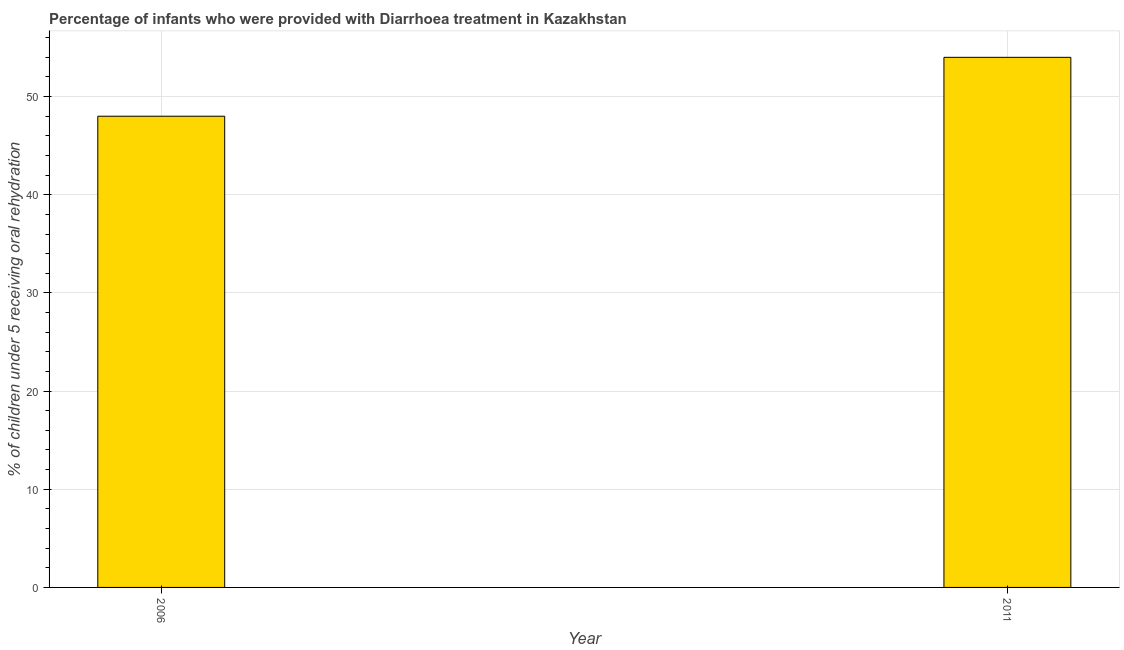Does the graph contain any zero values?
Provide a short and direct response. No. Does the graph contain grids?
Provide a short and direct response. Yes. What is the title of the graph?
Your answer should be very brief. Percentage of infants who were provided with Diarrhoea treatment in Kazakhstan. What is the label or title of the X-axis?
Keep it short and to the point. Year. What is the label or title of the Y-axis?
Your answer should be compact. % of children under 5 receiving oral rehydration. What is the percentage of children who were provided with treatment diarrhoea in 2011?
Offer a terse response. 54. Across all years, what is the maximum percentage of children who were provided with treatment diarrhoea?
Offer a very short reply. 54. Across all years, what is the minimum percentage of children who were provided with treatment diarrhoea?
Provide a succinct answer. 48. What is the sum of the percentage of children who were provided with treatment diarrhoea?
Make the answer very short. 102. What is the difference between the percentage of children who were provided with treatment diarrhoea in 2006 and 2011?
Provide a succinct answer. -6. What is the average percentage of children who were provided with treatment diarrhoea per year?
Provide a short and direct response. 51. In how many years, is the percentage of children who were provided with treatment diarrhoea greater than 48 %?
Offer a terse response. 1. Do a majority of the years between 2006 and 2011 (inclusive) have percentage of children who were provided with treatment diarrhoea greater than 12 %?
Provide a succinct answer. Yes. What is the ratio of the percentage of children who were provided with treatment diarrhoea in 2006 to that in 2011?
Ensure brevity in your answer.  0.89. Is the percentage of children who were provided with treatment diarrhoea in 2006 less than that in 2011?
Ensure brevity in your answer.  Yes. Are all the bars in the graph horizontal?
Give a very brief answer. No. How many years are there in the graph?
Ensure brevity in your answer.  2. What is the difference between two consecutive major ticks on the Y-axis?
Offer a very short reply. 10. Are the values on the major ticks of Y-axis written in scientific E-notation?
Offer a terse response. No. What is the % of children under 5 receiving oral rehydration in 2011?
Keep it short and to the point. 54. What is the difference between the % of children under 5 receiving oral rehydration in 2006 and 2011?
Provide a short and direct response. -6. What is the ratio of the % of children under 5 receiving oral rehydration in 2006 to that in 2011?
Offer a terse response. 0.89. 